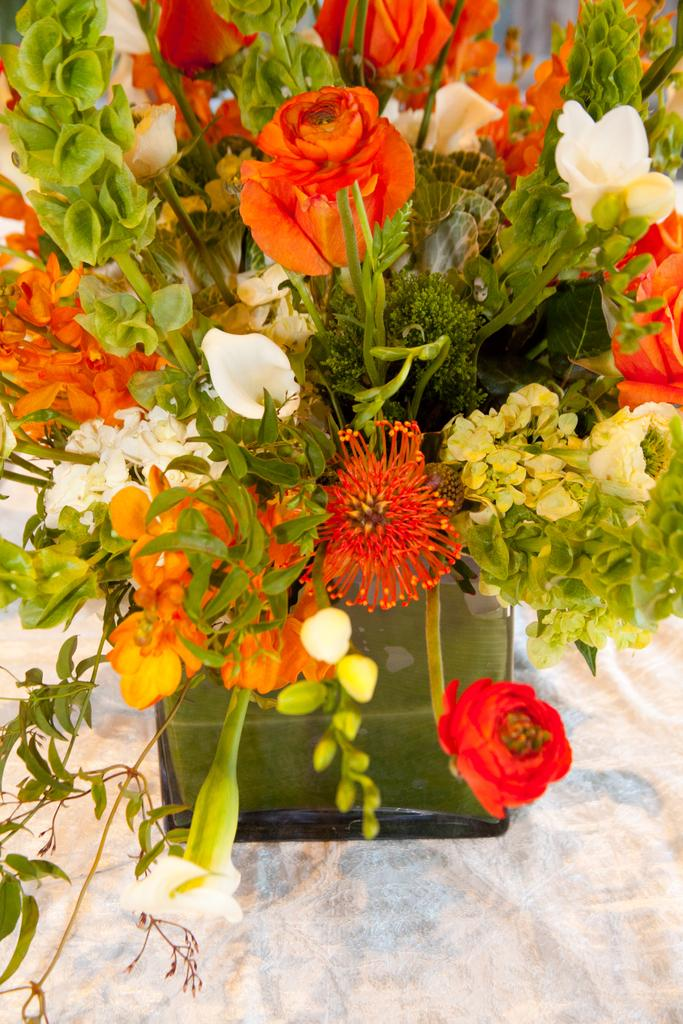What is the primary color of the cloth in the image? The primary color of the cloth in the image is white. What is placed on top of the white cloth? There is a flower bouquet on the white cloth. What type of drink is being served under the moon in the image? There is no drink or moon present in the image; it only features a white cloth and a flower bouquet. 